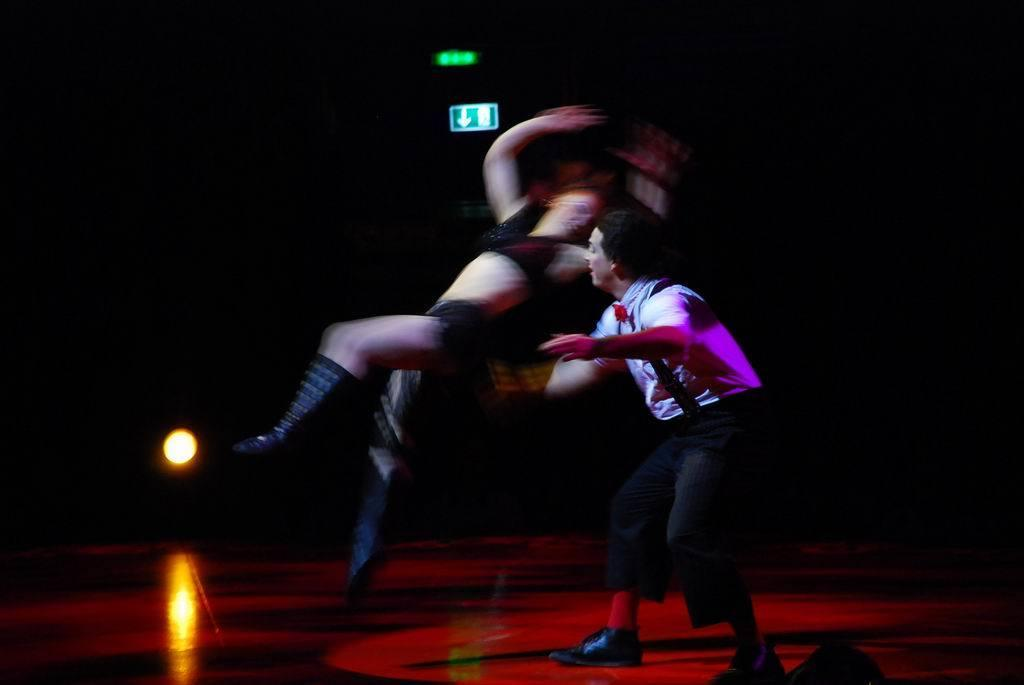How many people are on the floor in the image? There are two people on the floor in the image. What can be seen in the background of the image? There are a few lights in the background, and the background is dark. What type of lock is being used during the operation in the image? There is no operation or lock present in the image; it features two people on the floor with a dark background. 